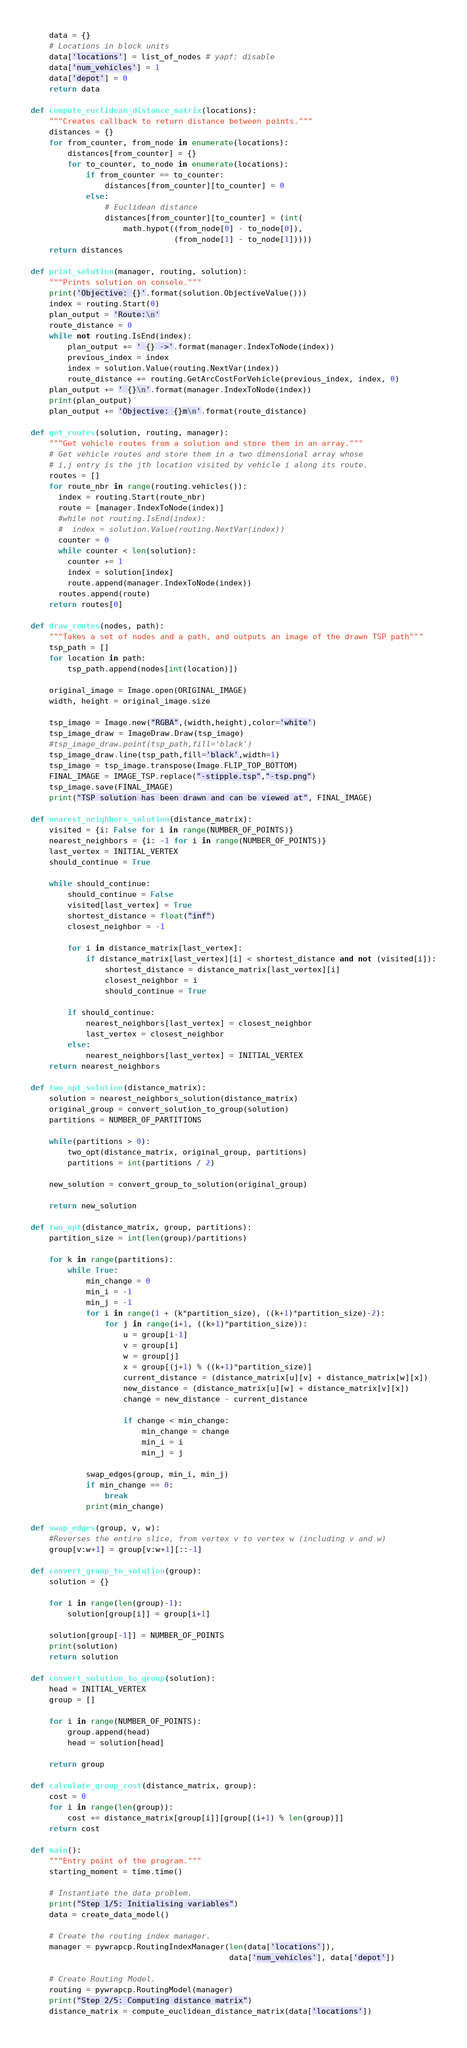<code> <loc_0><loc_0><loc_500><loc_500><_Python_>    data = {}
    # Locations in block units
    data['locations'] = list_of_nodes # yapf: disable
    data['num_vehicles'] = 1
    data['depot'] = 0
    return data

def compute_euclidean_distance_matrix(locations):
    """Creates callback to return distance between points."""
    distances = {}
    for from_counter, from_node in enumerate(locations):
        distances[from_counter] = {}
        for to_counter, to_node in enumerate(locations):
            if from_counter == to_counter:
                distances[from_counter][to_counter] = 0
            else:
                # Euclidean distance
                distances[from_counter][to_counter] = (int(
                    math.hypot((from_node[0] - to_node[0]),
                               (from_node[1] - to_node[1]))))
    return distances

def print_solution(manager, routing, solution):
    """Prints solution on console."""
    print('Objective: {}'.format(solution.ObjectiveValue()))
    index = routing.Start(0)
    plan_output = 'Route:\n'
    route_distance = 0
    while not routing.IsEnd(index):
        plan_output += ' {} ->'.format(manager.IndexToNode(index))
        previous_index = index
        index = solution.Value(routing.NextVar(index))
        route_distance += routing.GetArcCostForVehicle(previous_index, index, 0)
    plan_output += ' {}\n'.format(manager.IndexToNode(index))
    print(plan_output)
    plan_output += 'Objective: {}m\n'.format(route_distance)

def get_routes(solution, routing, manager):
    """Get vehicle routes from a solution and store them in an array."""
    # Get vehicle routes and store them in a two dimensional array whose
    # i,j entry is the jth location visited by vehicle i along its route.
    routes = []
    for route_nbr in range(routing.vehicles()):
      index = routing.Start(route_nbr)
      route = [manager.IndexToNode(index)]
      #while not routing.IsEnd(index):
      #  index = solution.Value(routing.NextVar(index))
      counter = 0
      while counter < len(solution):
        counter += 1
        index = solution[index]
        route.append(manager.IndexToNode(index))
      routes.append(route)
    return routes[0]

def draw_routes(nodes, path):
    """Takes a set of nodes and a path, and outputs an image of the drawn TSP path"""
    tsp_path = []
    for location in path:
        tsp_path.append(nodes[int(location)])

    original_image = Image.open(ORIGINAL_IMAGE)
    width, height = original_image.size

    tsp_image = Image.new("RGBA",(width,height),color='white')
    tsp_image_draw = ImageDraw.Draw(tsp_image)
    #tsp_image_draw.point(tsp_path,fill='black')
    tsp_image_draw.line(tsp_path,fill='black',width=1)
    tsp_image = tsp_image.transpose(Image.FLIP_TOP_BOTTOM)
    FINAL_IMAGE = IMAGE_TSP.replace("-stipple.tsp","-tsp.png")
    tsp_image.save(FINAL_IMAGE)
    print("TSP solution has been drawn and can be viewed at", FINAL_IMAGE)

def nearest_neighbors_solution(distance_matrix):
    visited = {i: False for i in range(NUMBER_OF_POINTS)}
    nearest_neighbors = {i: -1 for i in range(NUMBER_OF_POINTS)}
    last_vertex = INITIAL_VERTEX
    should_continue = True

    while should_continue:
        should_continue = False
        visited[last_vertex] = True
        shortest_distance = float("inf")
        closest_neighbor = -1

        for i in distance_matrix[last_vertex]:
            if distance_matrix[last_vertex][i] < shortest_distance and not (visited[i]):
                shortest_distance = distance_matrix[last_vertex][i]
                closest_neighbor = i
                should_continue = True

        if should_continue:
            nearest_neighbors[last_vertex] = closest_neighbor
            last_vertex = closest_neighbor
        else:
            nearest_neighbors[last_vertex] = INITIAL_VERTEX
    return nearest_neighbors

def two_opt_solution(distance_matrix):
    solution = nearest_neighbors_solution(distance_matrix)
    original_group = convert_solution_to_group(solution)
    partitions = NUMBER_OF_PARTITIONS

    while(partitions > 0):
        two_opt(distance_matrix, original_group, partitions)
        partitions = int(partitions / 2)

    new_solution = convert_group_to_solution(original_group)

    return new_solution

def two_opt(distance_matrix, group, partitions):
    partition_size = int(len(group)/partitions)

    for k in range(partitions):
        while True:
            min_change = 0
            min_i = -1
            min_j = -1
            for i in range(1 + (k*partition_size), ((k+1)*partition_size)-2):
                for j in range(i+1, ((k+1)*partition_size)):
                    u = group[i-1]
                    v = group[i]
                    w = group[j]
                    x = group[(j+1) % ((k+1)*partition_size)]
                    current_distance = (distance_matrix[u][v] + distance_matrix[w][x])
                    new_distance = (distance_matrix[u][w] + distance_matrix[v][x])
                    change = new_distance - current_distance

                    if change < min_change:
                        min_change = change
                        min_i = i
                        min_j = j

            swap_edges(group, min_i, min_j)
            if min_change == 0:
                break
            print(min_change)

def swap_edges(group, v, w):
    #Reverses the entire slice, from vertex v to vertex w (including v and w)
    group[v:w+1] = group[v:w+1][::-1]

def convert_group_to_solution(group):
    solution = {}

    for i in range(len(group)-1):
        solution[group[i]] = group[i+1]

    solution[group[-1]] = NUMBER_OF_POINTS
    print(solution)
    return solution

def convert_solution_to_group(solution):
    head = INITIAL_VERTEX
    group = []

    for i in range(NUMBER_OF_POINTS):
        group.append(head)
        head = solution[head]

    return group

def calculate_group_cost(distance_matrix, group):
    cost = 0
    for i in range(len(group)):
        cost += distance_matrix[group[i]][group[(i+1) % len(group)]]
    return cost

def main():
    """Entry point of the program."""
    starting_moment = time.time()

    # Instantiate the data problem.
    print("Step 1/5: Initialising variables")
    data = create_data_model()

    # Create the routing index manager.
    manager = pywrapcp.RoutingIndexManager(len(data['locations']),
                                           data['num_vehicles'], data['depot'])

    # Create Routing Model.
    routing = pywrapcp.RoutingModel(manager)
    print("Step 2/5: Computing distance matrix")
    distance_matrix = compute_euclidean_distance_matrix(data['locations'])
</code> 